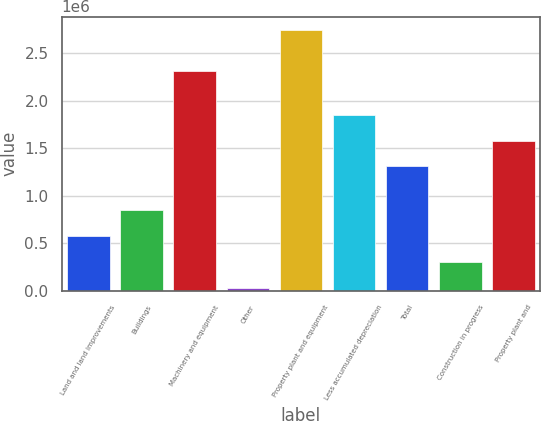Convert chart to OTSL. <chart><loc_0><loc_0><loc_500><loc_500><bar_chart><fcel>Land and land improvements<fcel>Buildings<fcel>Machinery and equipment<fcel>Other<fcel>Property plant and equipment<fcel>Less accumulated depreciation<fcel>Total<fcel>Construction in progress<fcel>Property plant and<nl><fcel>577540<fcel>848676<fcel>2.31083e+06<fcel>35267<fcel>2.74663e+06<fcel>1.85184e+06<fcel>1.30957e+06<fcel>306404<fcel>1.58071e+06<nl></chart> 